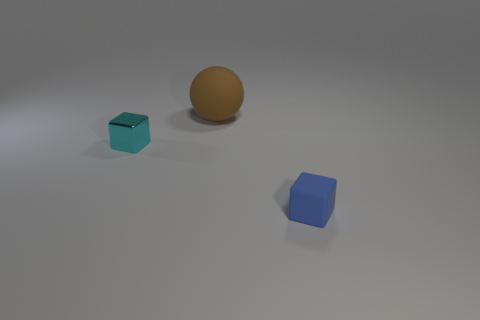Add 3 yellow metallic cubes. How many objects exist? 6 Subtract all cubes. How many objects are left? 1 Add 3 large matte cylinders. How many large matte cylinders exist? 3 Subtract 1 blue cubes. How many objects are left? 2 Subtract all brown spheres. Subtract all cyan shiny blocks. How many objects are left? 1 Add 2 small rubber things. How many small rubber things are left? 3 